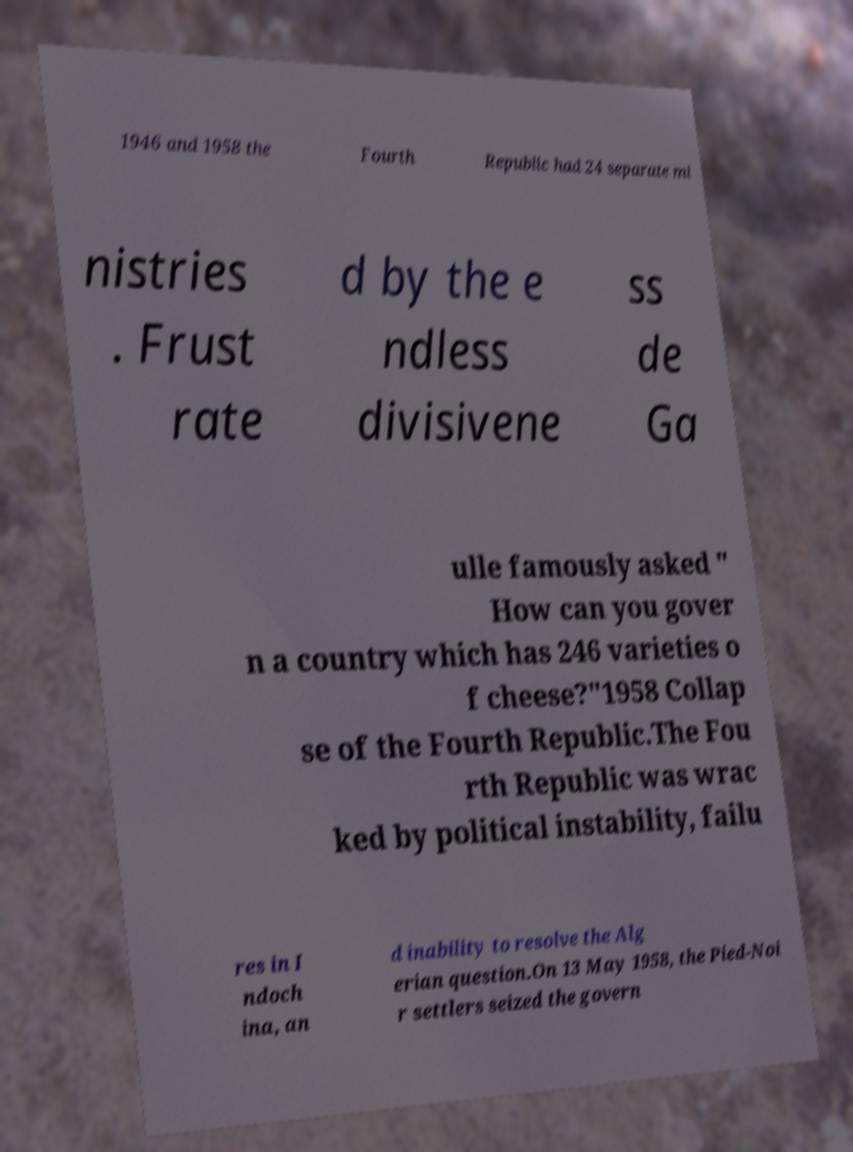Please identify and transcribe the text found in this image. 1946 and 1958 the Fourth Republic had 24 separate mi nistries . Frust rate d by the e ndless divisivene ss de Ga ulle famously asked " How can you gover n a country which has 246 varieties o f cheese?"1958 Collap se of the Fourth Republic.The Fou rth Republic was wrac ked by political instability, failu res in I ndoch ina, an d inability to resolve the Alg erian question.On 13 May 1958, the Pied-Noi r settlers seized the govern 